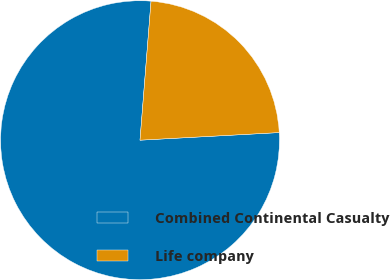Convert chart. <chart><loc_0><loc_0><loc_500><loc_500><pie_chart><fcel>Combined Continental Casualty<fcel>Life company<nl><fcel>77.13%<fcel>22.87%<nl></chart> 